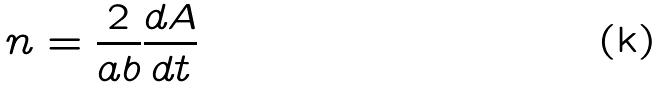Convert formula to latex. <formula><loc_0><loc_0><loc_500><loc_500>n = \frac { 2 } { a b } \frac { d A } { d t }</formula> 